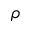Convert formula to latex. <formula><loc_0><loc_0><loc_500><loc_500>\rho</formula> 